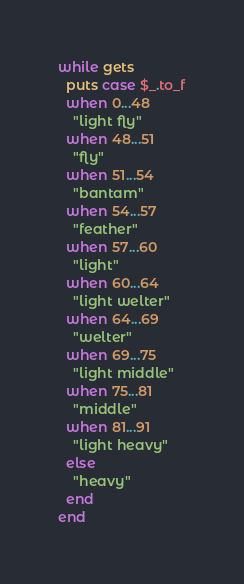Convert code to text. <code><loc_0><loc_0><loc_500><loc_500><_Ruby_>while gets
  puts case $_.to_f
  when 0...48
    "light fly"
  when 48...51
    "fly"
  when 51...54
    "bantam"
  when 54...57
    "feather"
  when 57...60
    "light"
  when 60...64
    "light welter"
  when 64...69
    "welter"
  when 69...75
    "light middle"
  when 75...81
    "middle"
  when 81...91
    "light heavy"
  else
    "heavy"
  end
end</code> 